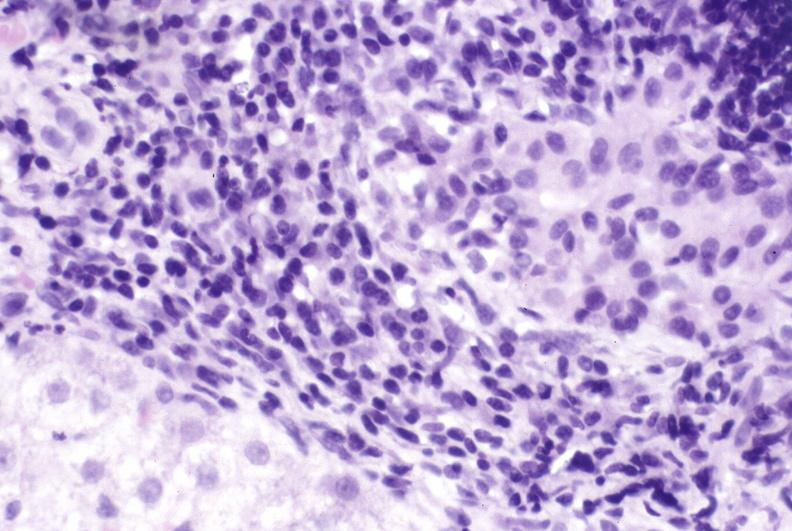s malformed base present?
Answer the question using a single word or phrase. No 